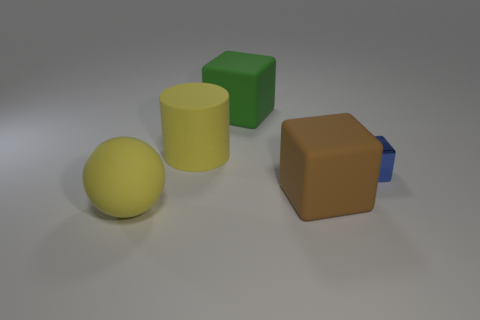How many blue metal things are right of the yellow matte object that is in front of the yellow rubber object that is behind the shiny cube?
Give a very brief answer. 1. Is there anything else that is the same size as the metal block?
Offer a very short reply. No. Do the green object and the block that is right of the brown rubber block have the same size?
Ensure brevity in your answer.  No. How many tiny cylinders are there?
Keep it short and to the point. 0. Does the yellow thing behind the large yellow matte ball have the same size as the shiny cube behind the big yellow rubber ball?
Ensure brevity in your answer.  No. There is another large thing that is the same shape as the green object; what color is it?
Make the answer very short. Brown. Does the big brown matte thing have the same shape as the green object?
Provide a short and direct response. Yes. The blue thing that is the same shape as the brown rubber thing is what size?
Your response must be concise. Small. What number of objects are made of the same material as the brown block?
Make the answer very short. 3. How many objects are either small gray balls or big cubes?
Provide a succinct answer. 2. 